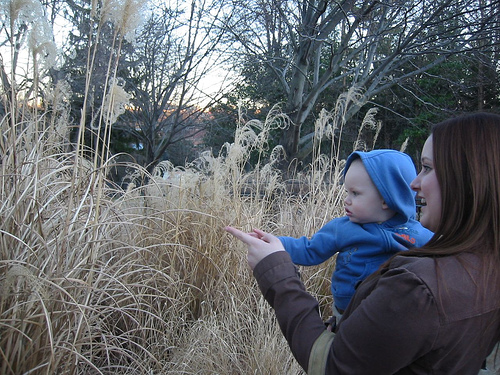<image>
Is there a baby in the grass? No. The baby is not contained within the grass. These objects have a different spatial relationship. Where is the baby in relation to the mommy? Is it in front of the mommy? Yes. The baby is positioned in front of the mommy, appearing closer to the camera viewpoint. 